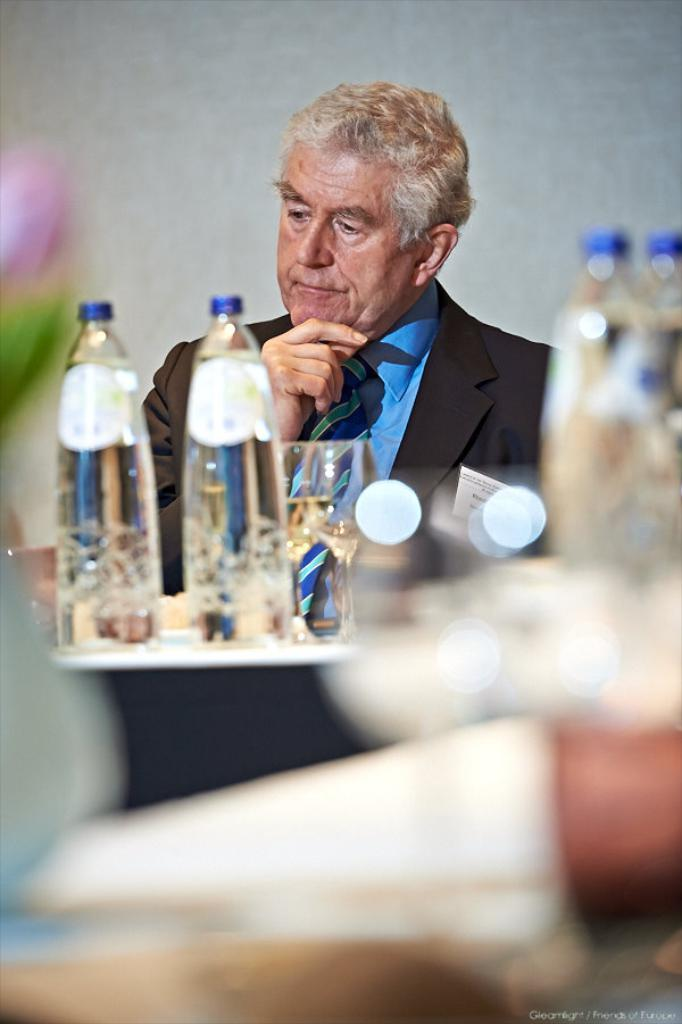Who is present in the image? There is a man in the image. What is the man doing in the image? The man is sitting in the image. Where is the man located in relation to the table? The man is in front of a table in the image. What can be seen on the table? There are water bottles and two glasses on the table in the image. Can you see a kitten playing with a fork in the image? No, there is no kitten or fork present in the image. 